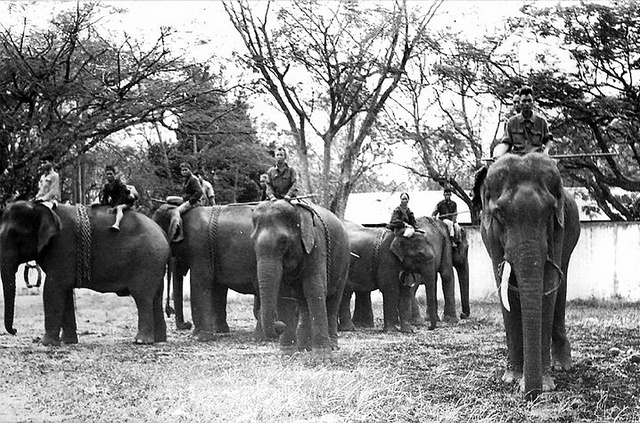Describe the objects in this image and their specific colors. I can see elephant in lightgray, black, gray, and darkgray tones, elephant in lightgray, black, gray, and darkgray tones, elephant in lightgray, gray, black, and darkgray tones, elephant in lightgray, black, gray, and darkgray tones, and elephant in lightgray, black, gray, and darkgray tones in this image. 